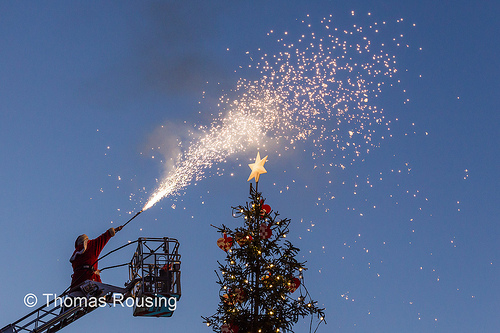<image>
Is the star on the christmas tree? Yes. Looking at the image, I can see the star is positioned on top of the christmas tree, with the christmas tree providing support. 